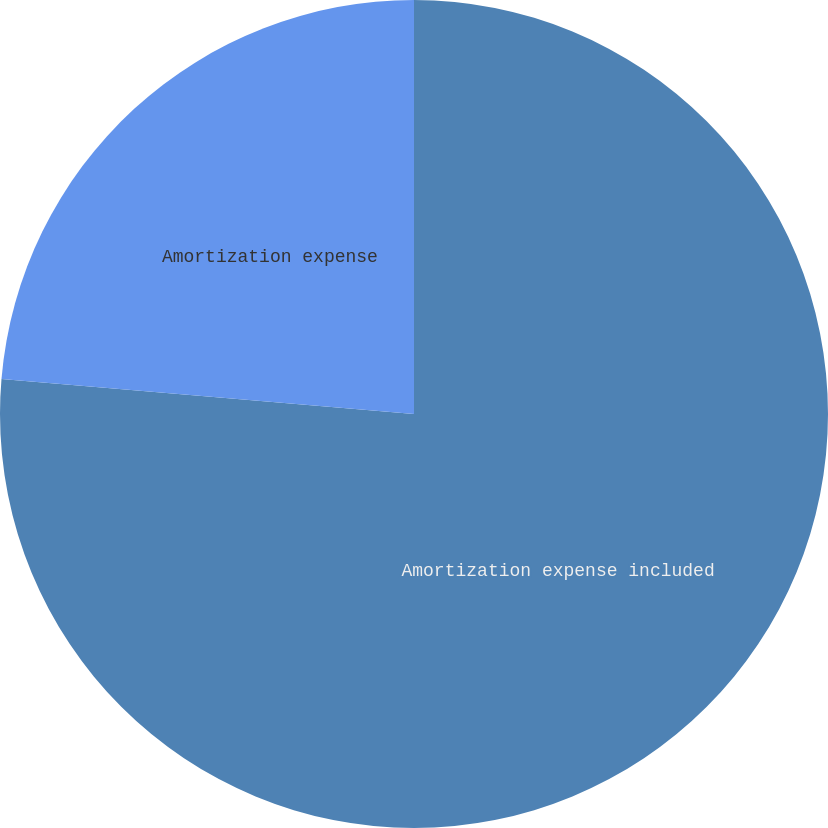Convert chart to OTSL. <chart><loc_0><loc_0><loc_500><loc_500><pie_chart><fcel>Amortization expense included<fcel>Amortization expense<nl><fcel>76.35%<fcel>23.65%<nl></chart> 